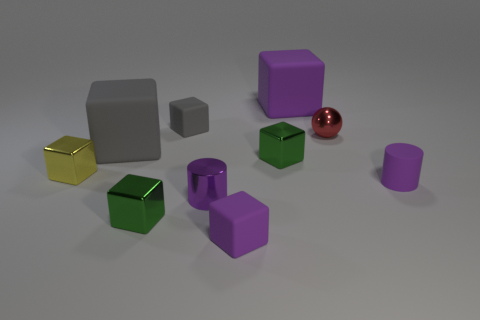How many other objects are the same material as the small red thing?
Your response must be concise. 4. There is a small red shiny thing; are there any shiny cubes behind it?
Provide a succinct answer. No. Do the metallic cylinder and the purple matte object that is behind the yellow cube have the same size?
Keep it short and to the point. No. There is a big matte cube in front of the small thing that is behind the red ball; what color is it?
Give a very brief answer. Gray. There is a tiny metal cube that is right of the large gray thing and behind the purple matte cylinder; what color is it?
Your answer should be compact. Green. Do the large thing that is to the right of the shiny cylinder and the rubber cylinder have the same color?
Offer a very short reply. Yes. Is the number of purple cylinders left of the small purple matte cube greater than the number of gray matte objects to the left of the tiny yellow shiny thing?
Provide a short and direct response. Yes. Is the number of yellow shiny objects greater than the number of tiny metallic cubes?
Your response must be concise. No. There is a matte thing that is both left of the purple metal object and in front of the tiny red shiny sphere; what is its size?
Your answer should be very brief. Large. There is a big purple matte thing; what shape is it?
Keep it short and to the point. Cube. 